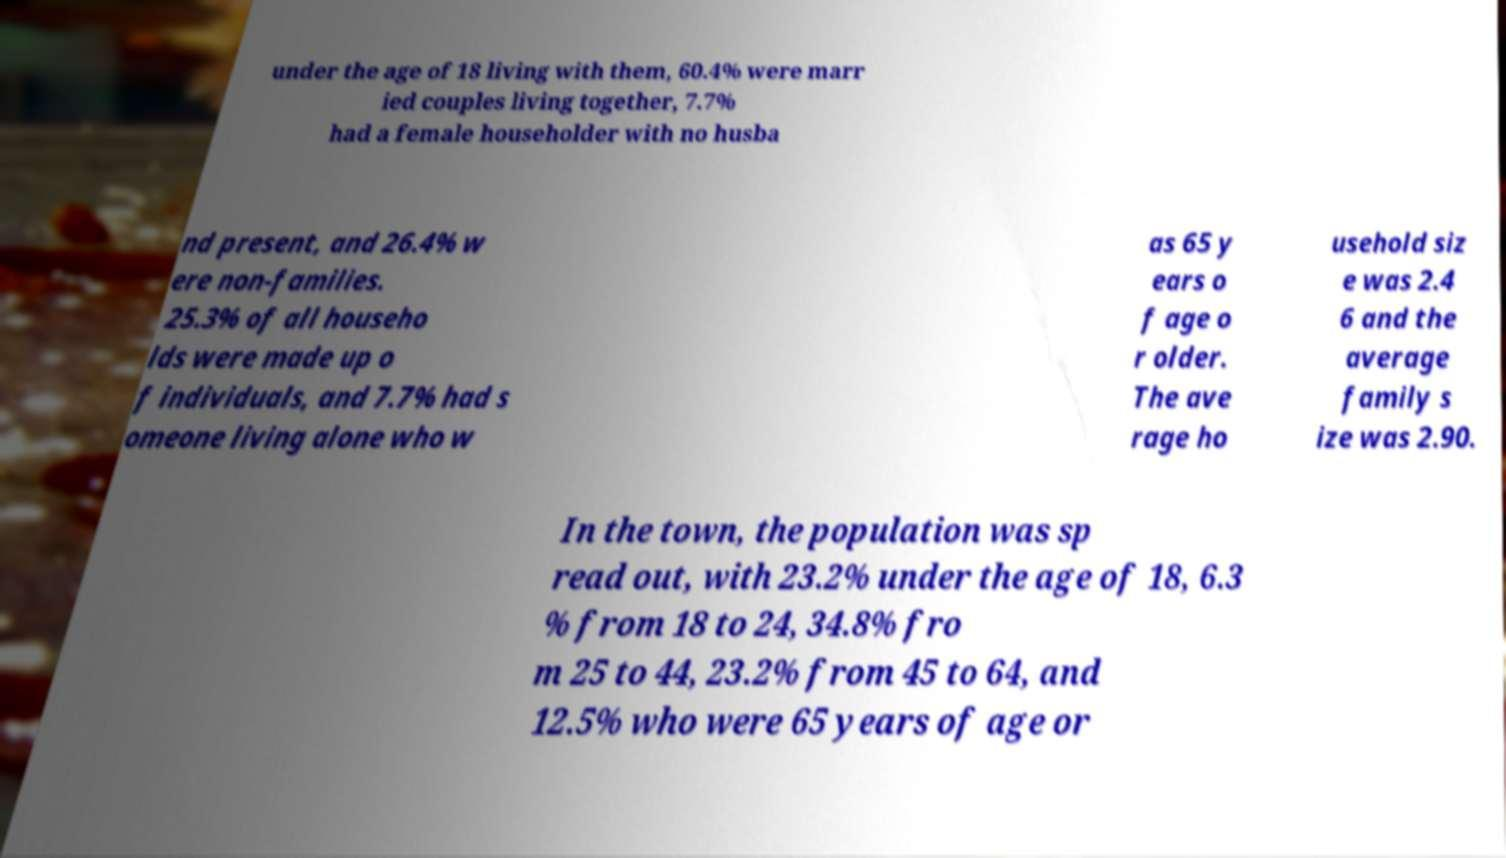Please identify and transcribe the text found in this image. under the age of 18 living with them, 60.4% were marr ied couples living together, 7.7% had a female householder with no husba nd present, and 26.4% w ere non-families. 25.3% of all househo lds were made up o f individuals, and 7.7% had s omeone living alone who w as 65 y ears o f age o r older. The ave rage ho usehold siz e was 2.4 6 and the average family s ize was 2.90. In the town, the population was sp read out, with 23.2% under the age of 18, 6.3 % from 18 to 24, 34.8% fro m 25 to 44, 23.2% from 45 to 64, and 12.5% who were 65 years of age or 